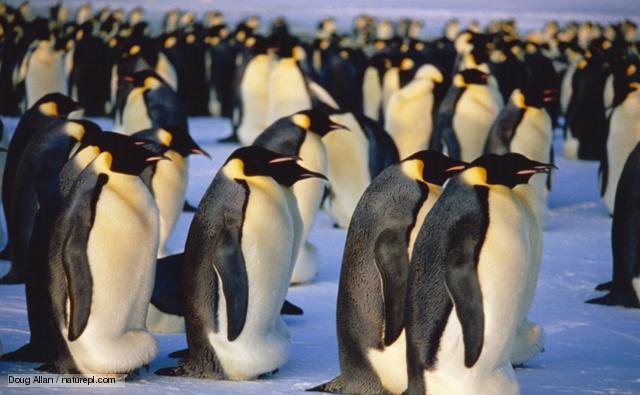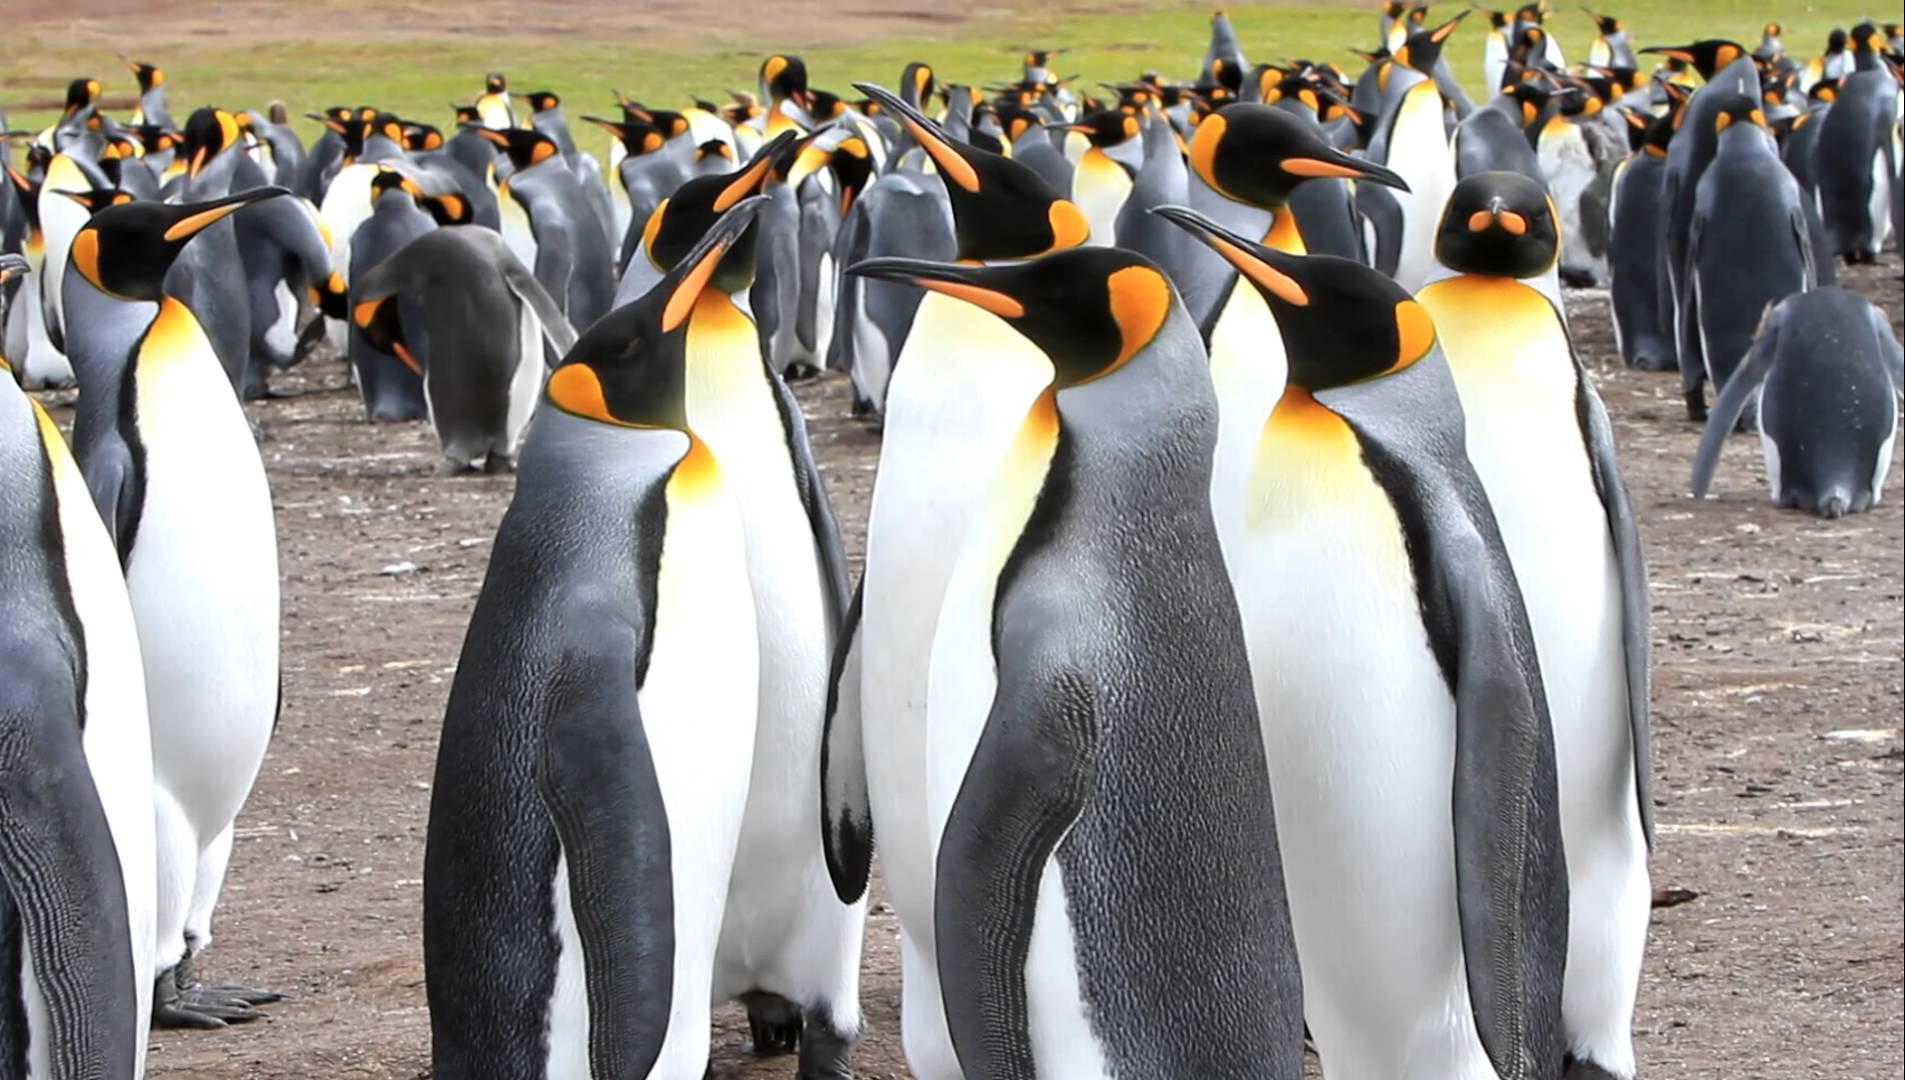The first image is the image on the left, the second image is the image on the right. Given the left and right images, does the statement "There are penguins standing on snow." hold true? Answer yes or no. Yes. The first image is the image on the left, the second image is the image on the right. Given the left and right images, does the statement "In one image, the foreground includes at least one penguin fully covered in fuzzy brown." hold true? Answer yes or no. No. 